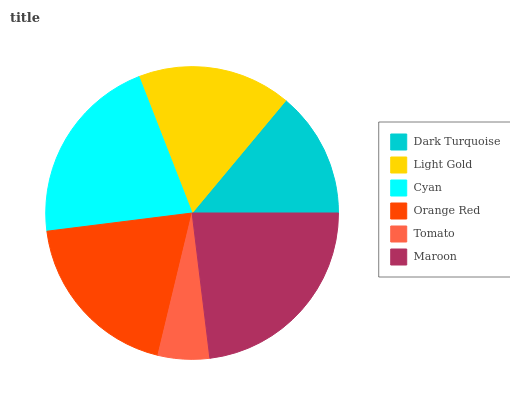Is Tomato the minimum?
Answer yes or no. Yes. Is Maroon the maximum?
Answer yes or no. Yes. Is Light Gold the minimum?
Answer yes or no. No. Is Light Gold the maximum?
Answer yes or no. No. Is Light Gold greater than Dark Turquoise?
Answer yes or no. Yes. Is Dark Turquoise less than Light Gold?
Answer yes or no. Yes. Is Dark Turquoise greater than Light Gold?
Answer yes or no. No. Is Light Gold less than Dark Turquoise?
Answer yes or no. No. Is Orange Red the high median?
Answer yes or no. Yes. Is Light Gold the low median?
Answer yes or no. Yes. Is Dark Turquoise the high median?
Answer yes or no. No. Is Maroon the low median?
Answer yes or no. No. 